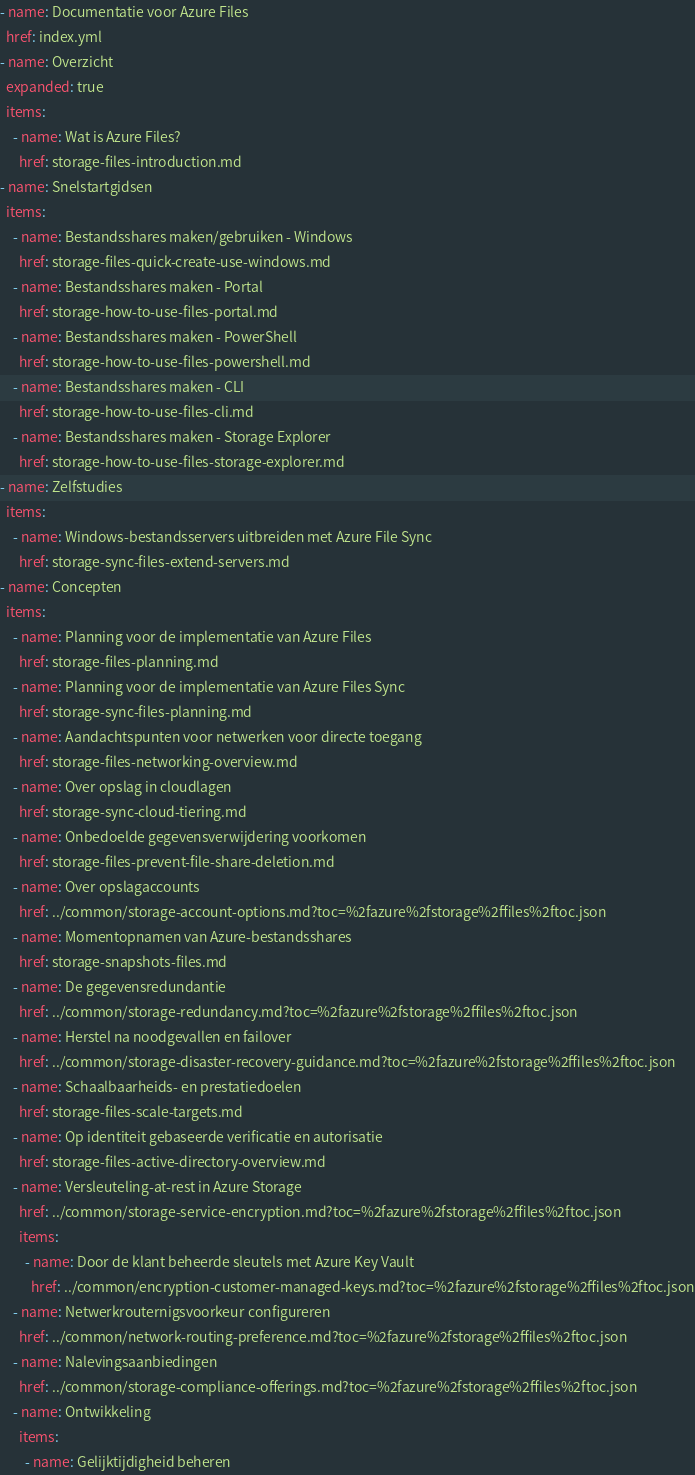<code> <loc_0><loc_0><loc_500><loc_500><_YAML_>- name: Documentatie voor Azure Files
  href: index.yml
- name: Overzicht
  expanded: true
  items:
    - name: Wat is Azure Files?
      href: storage-files-introduction.md
- name: Snelstartgidsen
  items:
    - name: Bestandsshares maken/gebruiken - Windows
      href: storage-files-quick-create-use-windows.md
    - name: Bestandsshares maken - Portal
      href: storage-how-to-use-files-portal.md
    - name: Bestandsshares maken - PowerShell
      href: storage-how-to-use-files-powershell.md
    - name: Bestandsshares maken - CLI
      href: storage-how-to-use-files-cli.md
    - name: Bestandsshares maken - Storage Explorer
      href: storage-how-to-use-files-storage-explorer.md
- name: Zelfstudies
  items:
    - name: Windows-bestandsservers uitbreiden met Azure File Sync
      href: storage-sync-files-extend-servers.md
- name: Concepten
  items:
    - name: Planning voor de implementatie van Azure Files
      href: storage-files-planning.md
    - name: Planning voor de implementatie van Azure Files Sync
      href: storage-sync-files-planning.md
    - name: Aandachtspunten voor netwerken voor directe toegang
      href: storage-files-networking-overview.md
    - name: Over opslag in cloudlagen
      href: storage-sync-cloud-tiering.md
    - name: Onbedoelde gegevensverwijdering voorkomen
      href: storage-files-prevent-file-share-deletion.md
    - name: Over opslagaccounts
      href: ../common/storage-account-options.md?toc=%2fazure%2fstorage%2ffiles%2ftoc.json
    - name: Momentopnamen van Azure-bestandsshares
      href: storage-snapshots-files.md
    - name: De gegevensredundantie
      href: ../common/storage-redundancy.md?toc=%2fazure%2fstorage%2ffiles%2ftoc.json
    - name: Herstel na noodgevallen en failover
      href: ../common/storage-disaster-recovery-guidance.md?toc=%2fazure%2fstorage%2ffiles%2ftoc.json
    - name: Schaalbaarheids- en prestatiedoelen
      href: storage-files-scale-targets.md
    - name: Op identiteit gebaseerde verificatie en autorisatie
      href: storage-files-active-directory-overview.md
    - name: Versleuteling-at-rest in Azure Storage
      href: ../common/storage-service-encryption.md?toc=%2fazure%2fstorage%2ffiles%2ftoc.json
      items:
        - name: Door de klant beheerde sleutels met Azure Key Vault
          href: ../common/encryption-customer-managed-keys.md?toc=%2fazure%2fstorage%2ffiles%2ftoc.json
    - name: Netwerkrouternigsvoorkeur configureren
      href: ../common/network-routing-preference.md?toc=%2fazure%2fstorage%2ffiles%2ftoc.json
    - name: Nalevingsaanbiedingen
      href: ../common/storage-compliance-offerings.md?toc=%2fazure%2fstorage%2ffiles%2ftoc.json
    - name: Ontwikkeling
      items:
        - name: Gelijktijdigheid beheren</code> 